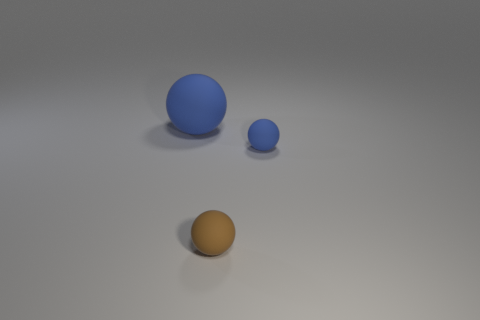What number of metallic things are either tiny things or small cyan cylinders?
Make the answer very short. 0. What color is the big matte thing that is the same shape as the tiny brown thing?
Provide a short and direct response. Blue. How many objects are either tiny brown shiny spheres or small matte objects?
Ensure brevity in your answer.  2. How many small objects are either blue matte spheres or blue cylinders?
Provide a short and direct response. 1. What number of other things are there of the same color as the big ball?
Ensure brevity in your answer.  1. There is a blue rubber thing in front of the rubber sphere that is behind the small blue ball; how many blue balls are behind it?
Offer a very short reply. 1. Does the blue matte object that is to the left of the brown rubber sphere have the same size as the tiny blue matte sphere?
Ensure brevity in your answer.  No. Are there fewer big blue matte things to the right of the large thing than tiny blue rubber spheres in front of the tiny brown sphere?
Ensure brevity in your answer.  No. Are there fewer tiny balls in front of the big matte ball than small brown spheres?
Offer a terse response. No. What is the material of the other object that is the same color as the large matte thing?
Ensure brevity in your answer.  Rubber. 